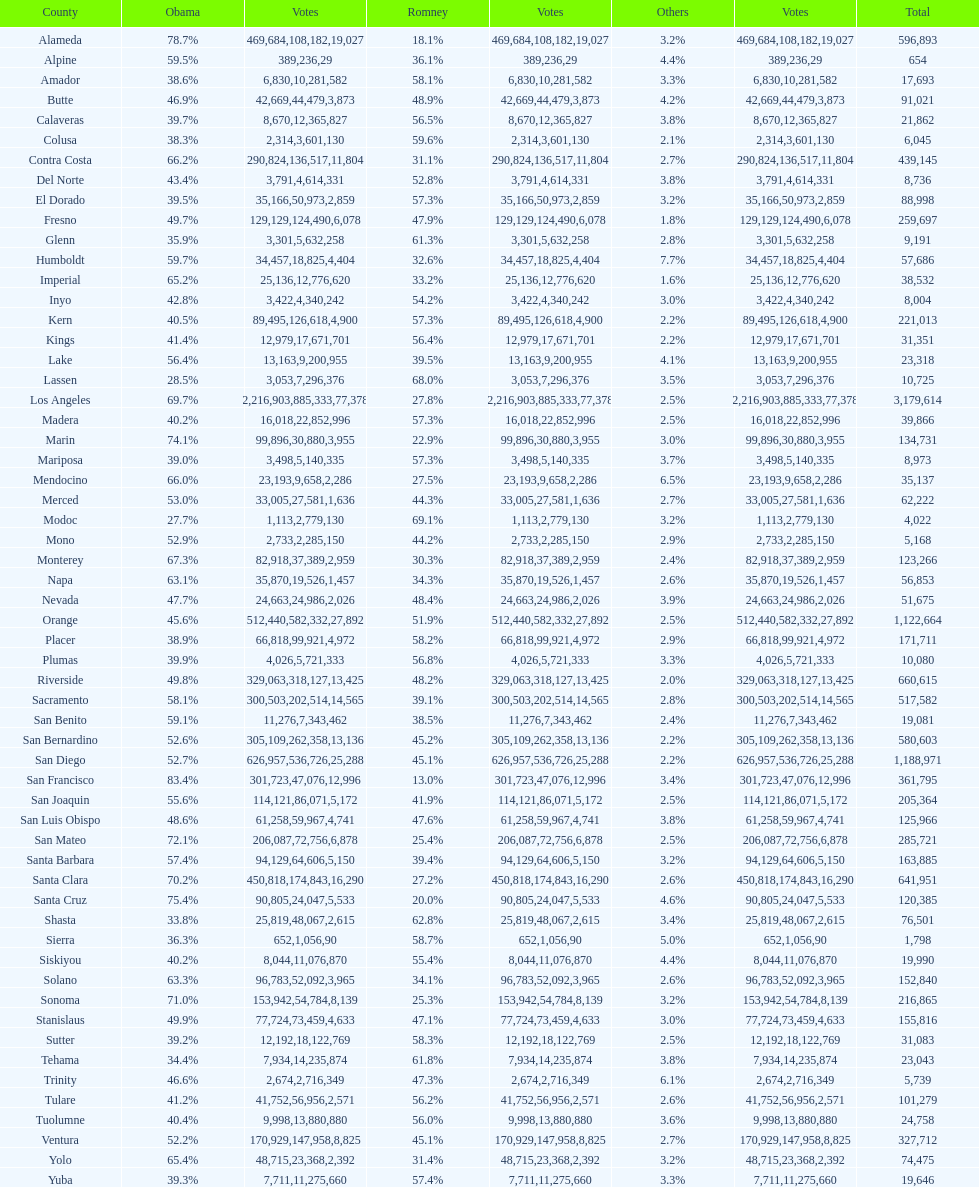In alameda county, did romney secure more or less votes than obama? Less. 